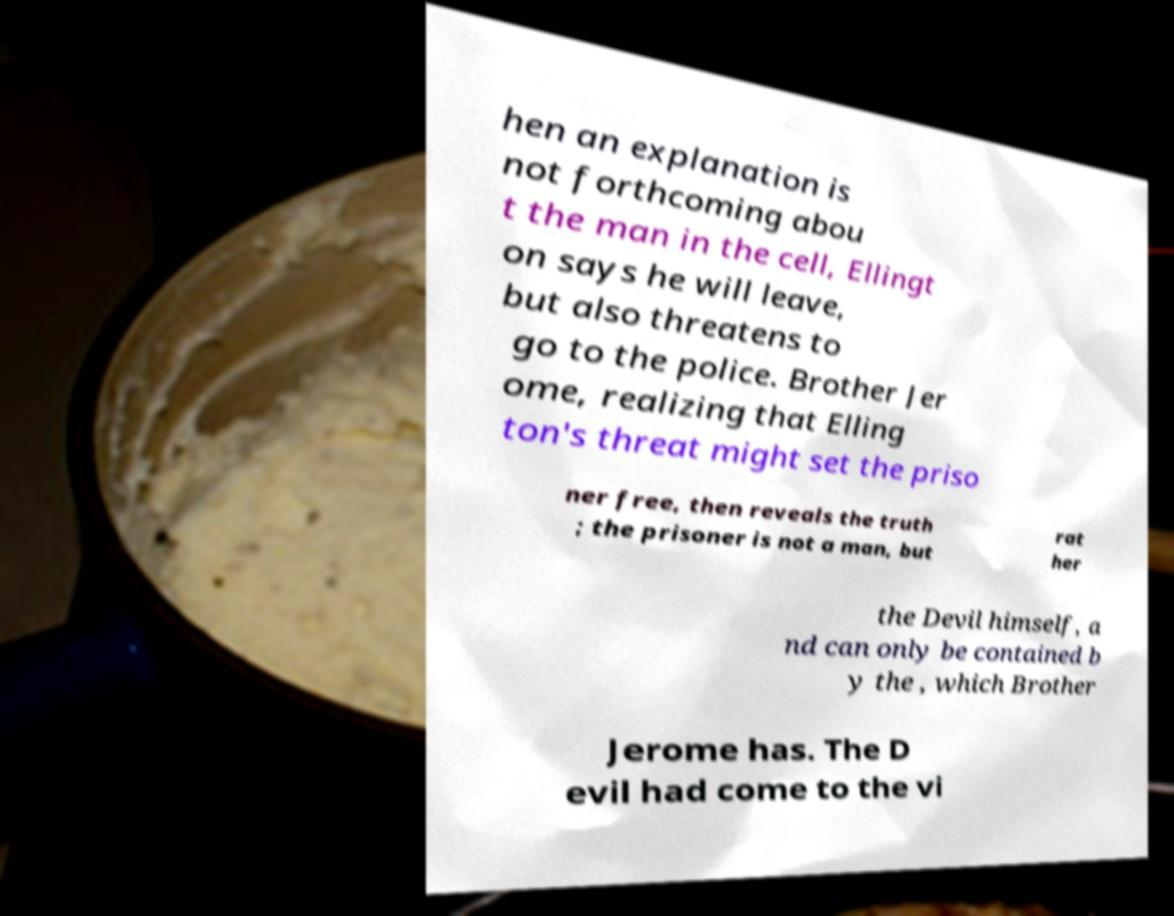I need the written content from this picture converted into text. Can you do that? hen an explanation is not forthcoming abou t the man in the cell, Ellingt on says he will leave, but also threatens to go to the police. Brother Jer ome, realizing that Elling ton's threat might set the priso ner free, then reveals the truth ; the prisoner is not a man, but rat her the Devil himself, a nd can only be contained b y the , which Brother Jerome has. The D evil had come to the vi 